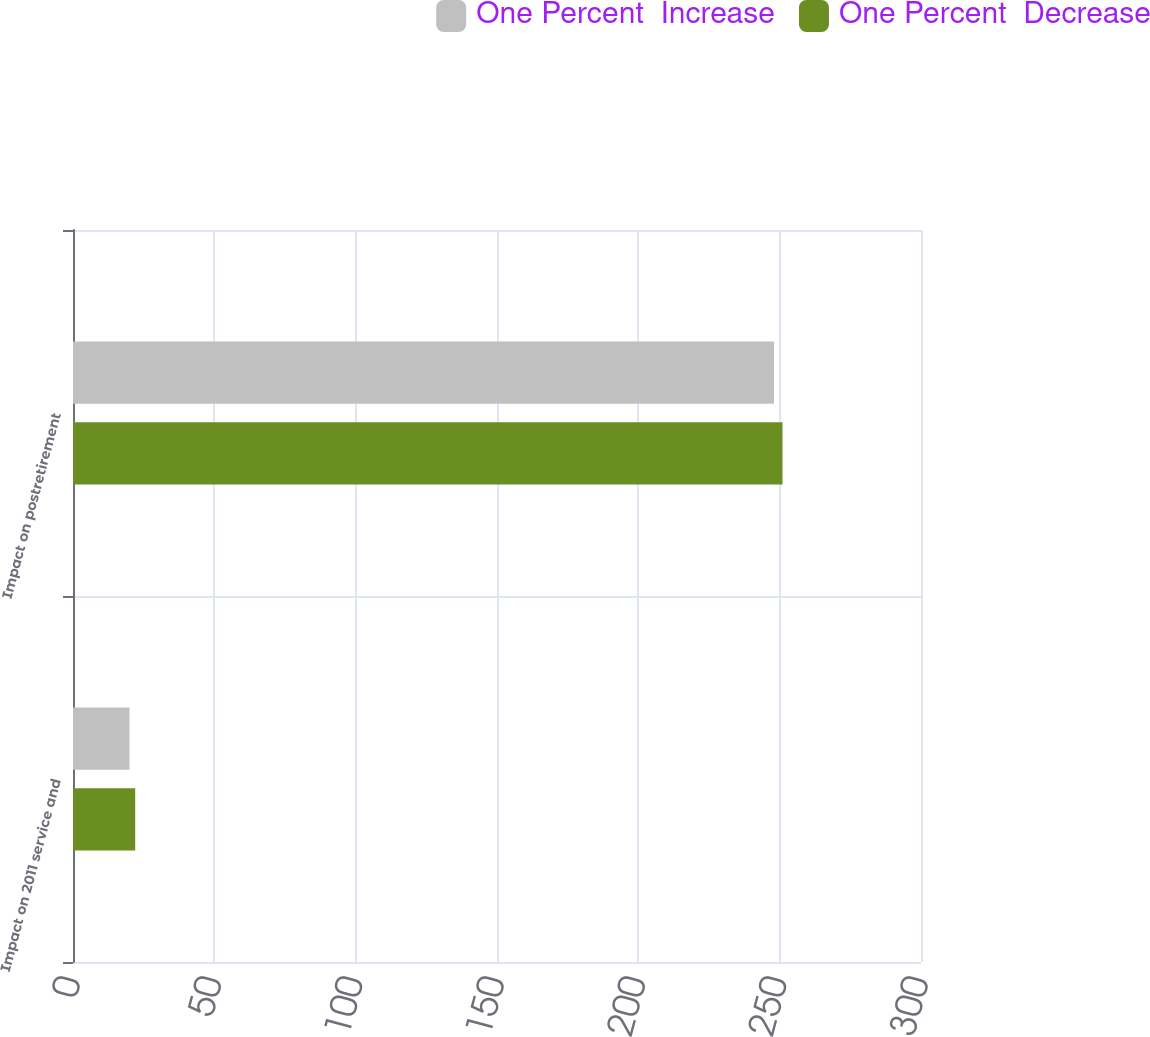<chart> <loc_0><loc_0><loc_500><loc_500><stacked_bar_chart><ecel><fcel>Impact on 2011 service and<fcel>Impact on postretirement<nl><fcel>One Percent  Increase<fcel>20<fcel>248<nl><fcel>One Percent  Decrease<fcel>22<fcel>251<nl></chart> 